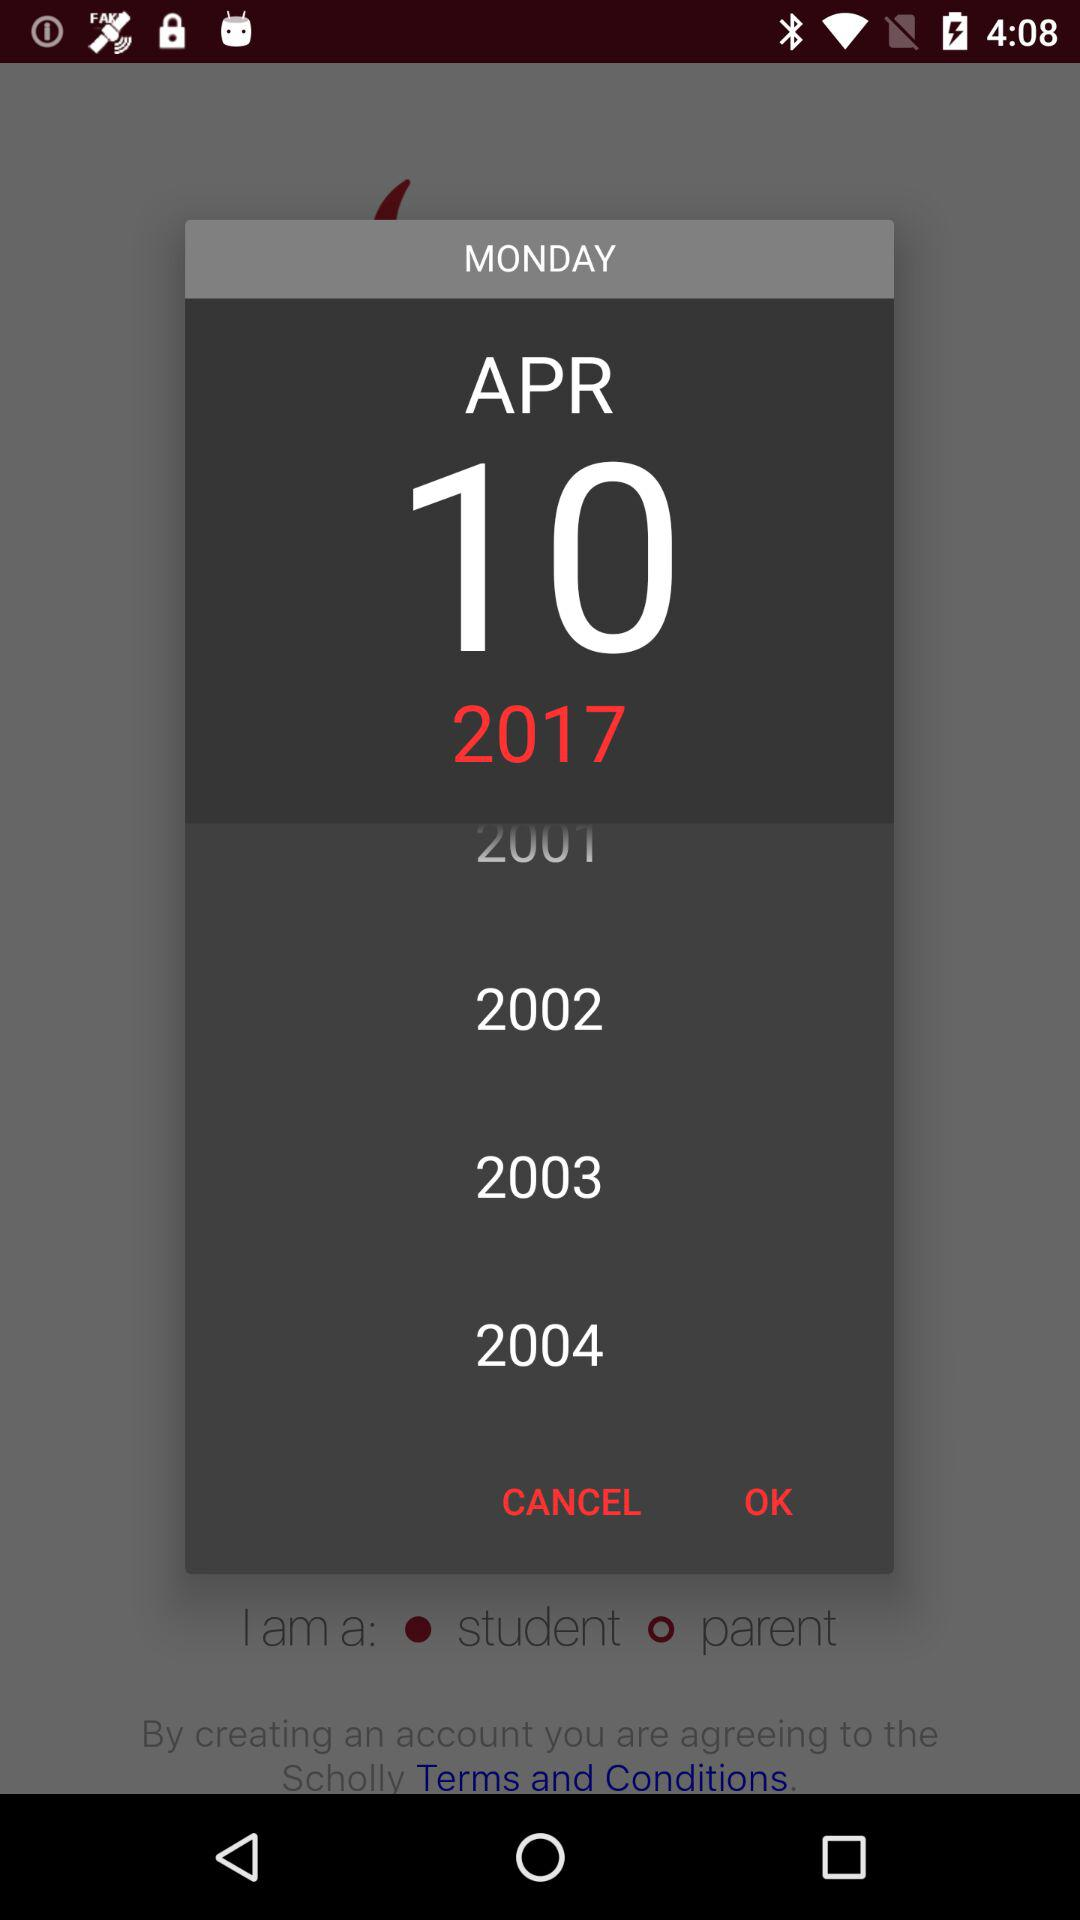Which date is selected? The selected date is Monday, April 10, 2017. 